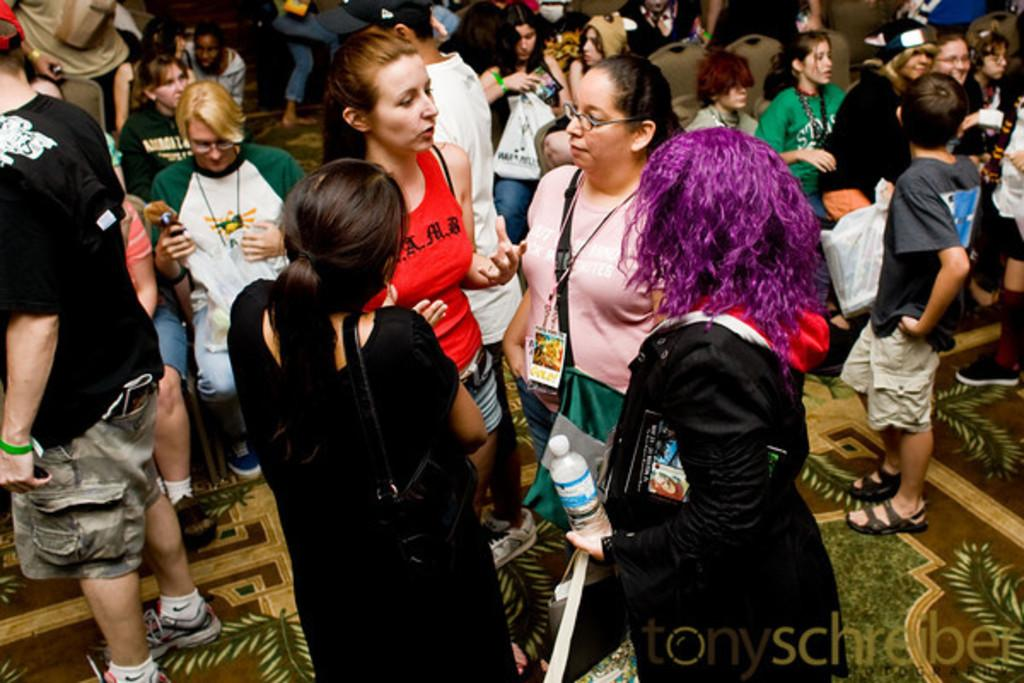How many people are present in the image? There are many people in the image. What are some of the positions the people are in? Some people are standing, and some people are sitting. What are the people holding in their hands? There are people holding items in their hands. What type of marble is being used to create the land in the image? There is no mention of land or marble in the image; it primarily features people in various positions. 